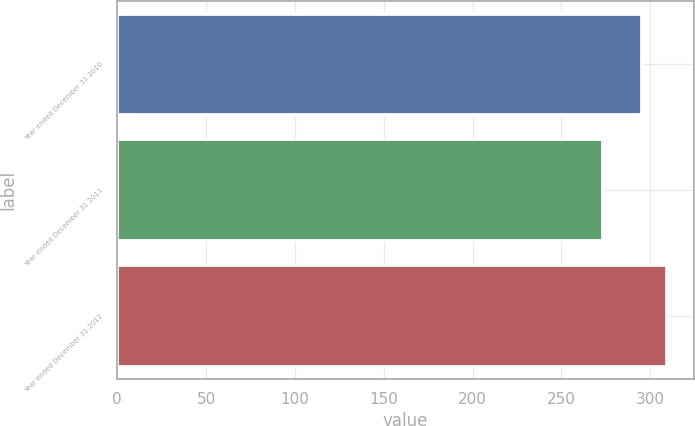Convert chart. <chart><loc_0><loc_0><loc_500><loc_500><bar_chart><fcel>Year ended December 31 2010<fcel>Year ended December 31 2011<fcel>Year ended December 31 2012<nl><fcel>295<fcel>273<fcel>309<nl></chart> 